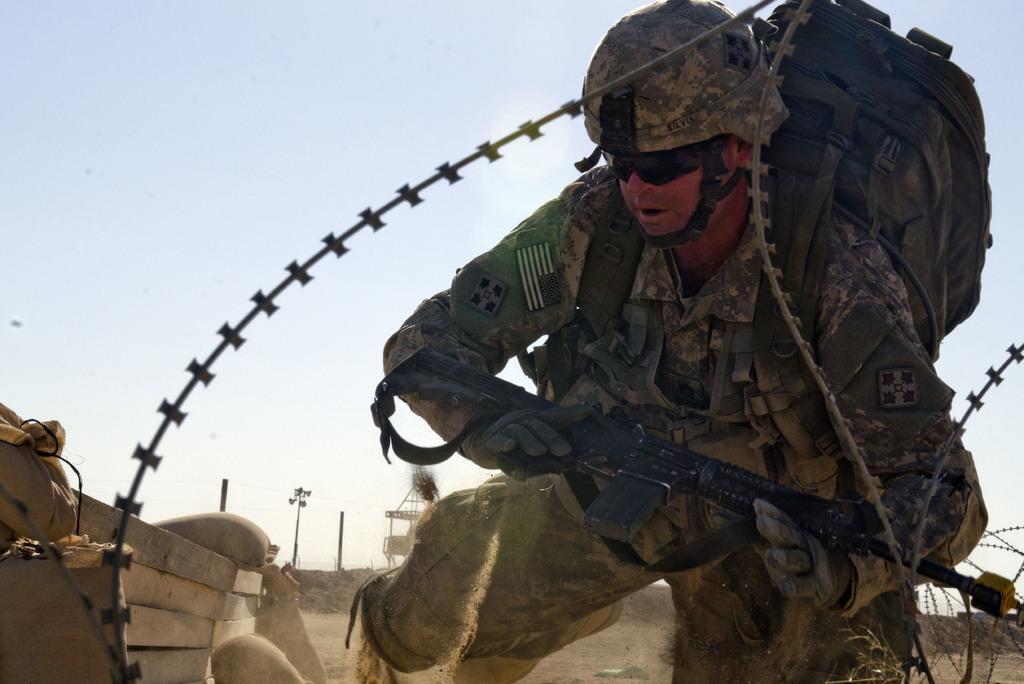Can you describe this image briefly? In this image there is one person is wearing a uniform and he is wearing a bag and a helmet, and he is holding a gun and there is fence, some boxes, bags and some objects. And in the background there are poles and shelter and at the top there is sky, and at the bottom there is sand and some rocks. 